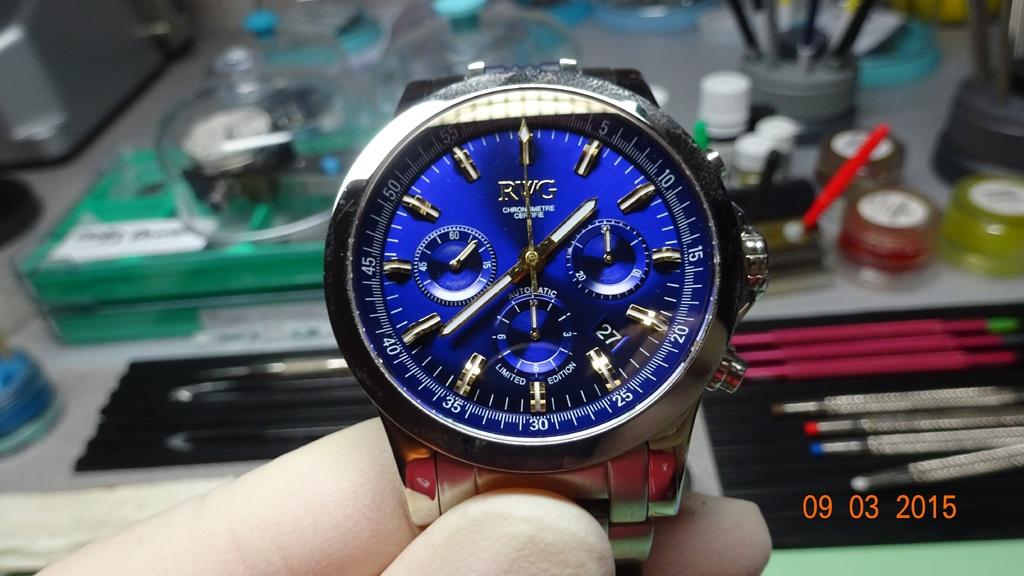Provide a one-sentence caption for the provided image. A blue watch gives the time of 1:39. 